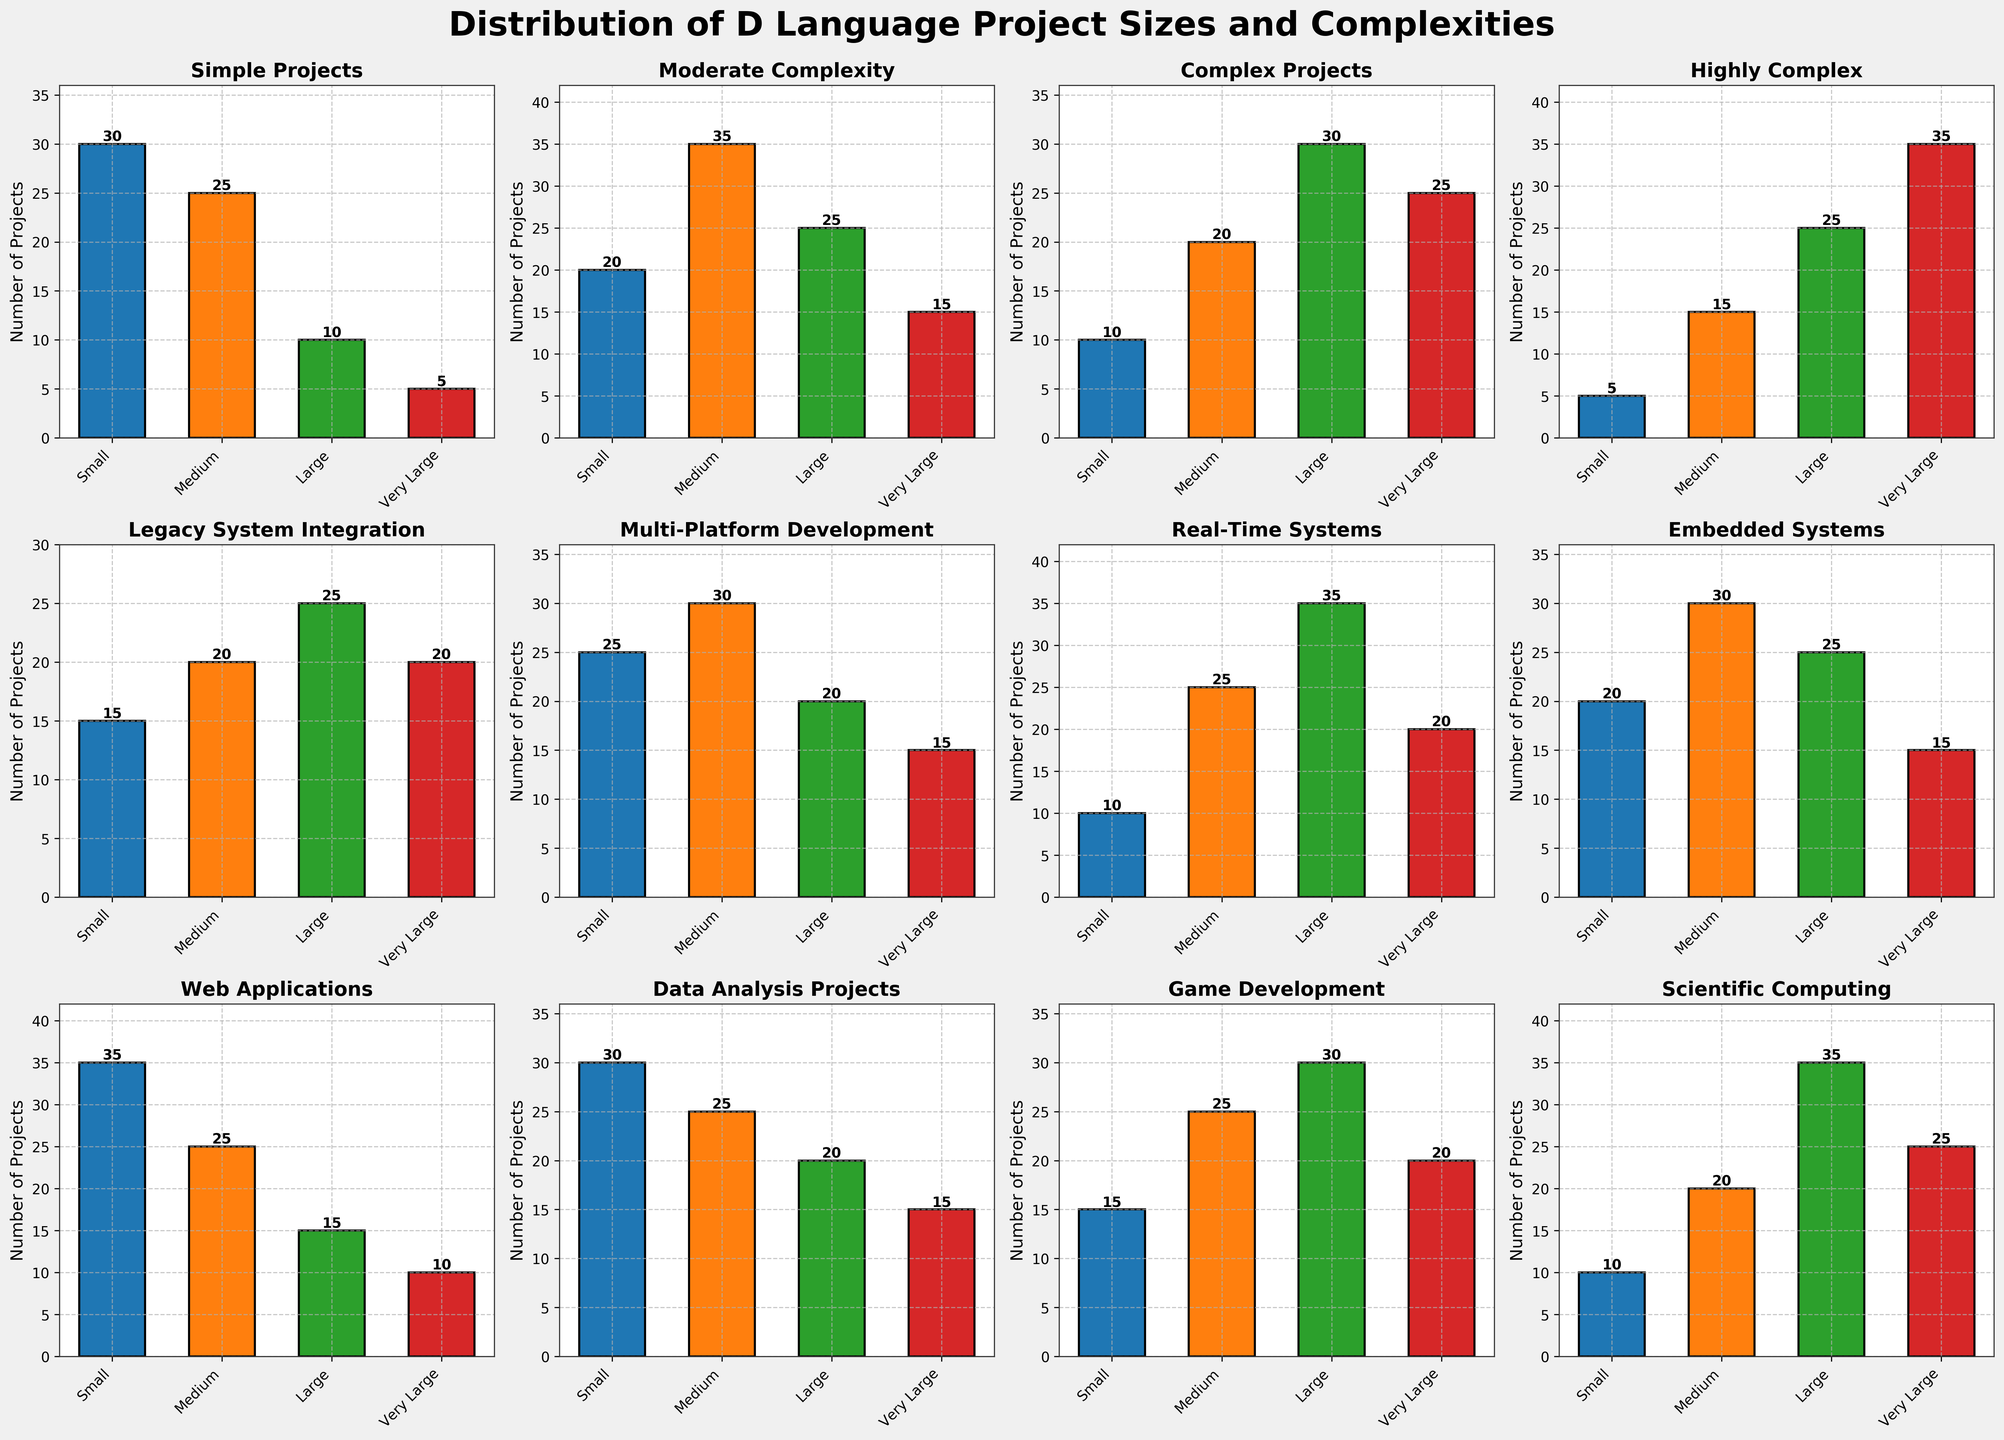What's the most common project size for Simple Projects? The Simple Projects bar chart shows the highest bar in the 'Small' category. By visually inspecting the bar heights, the 'Small' category has the highest count.
Answer: Small How many more Highly Complex projects are Very Large compared to Small? For Highly Complex projects, the bar for Very Large is 35, and the bar for Small is 5. Calculate the difference: 35 - 5.
Answer: 30 For which category is the number of Large Web Applications less than the number of Large Game Development projects? The bar for Large in the Web Applications category is 15, and the bar for Large in the Game Development category is 30. Comparing the two, 15 is less than 30.
Answer: Web Applications Which project category has the highest number of Medium-sized projects? By visually comparing the heights of the bars for the Medium category across all subplots, the highest bar is in 'Moderate Complexity Projects' with a count of 35.
Answer: Moderate Complexity What is the total number of Small Embedded Systems and Small Web Applications projects? Add the counts of Small Embedded Systems (20) and Small Web Applications (35): 20 + 35.
Answer: 55 Are there more Medium or Large Scientific Computing projects? The bar for Medium Scientific Computing projects stands at 20, while the Large category is 35. Comparing the two bars, the Large category is greater.
Answer: Large What is the difference between the number of Small and Very Large Real-Time Systems projects? For Real-Time Systems, the Small category has 10 projects and the Very Large category has 20 projects. Calculate the difference: 20 - 10.
Answer: 10 How many categories have exactly 25 Medium-sized projects? By inspecting the heights of the bars in the Medium category across all subplots, the categories with exactly 25 Medium-sized projects are Simple Projects, Web Applications, and Data Analysis Projects. Count these categories.
Answer: 3 